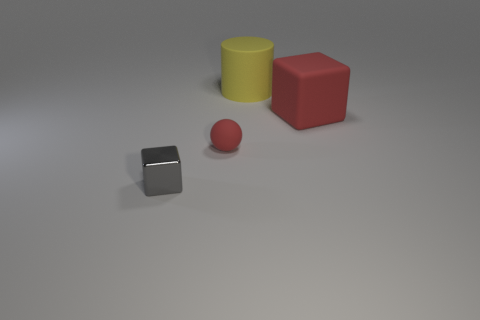What is the thing that is both behind the tiny gray shiny thing and in front of the matte cube made of?
Provide a succinct answer. Rubber. How many gray metal objects have the same shape as the large red object?
Provide a short and direct response. 1. There is a cube in front of the object that is right of the big object to the left of the big block; what size is it?
Ensure brevity in your answer.  Small. Are there more gray objects in front of the gray metal cube than gray spheres?
Your answer should be very brief. No. Is there a yellow cylinder?
Your answer should be compact. Yes. How many other blocks have the same size as the red block?
Ensure brevity in your answer.  0. Is the number of red rubber things to the left of the ball greater than the number of large objects in front of the gray shiny thing?
Your answer should be compact. No. There is a red sphere that is the same size as the metallic block; what is its material?
Provide a short and direct response. Rubber. The gray shiny thing has what shape?
Your answer should be very brief. Cube. What number of gray objects are either large cubes or metallic objects?
Your answer should be compact. 1. 